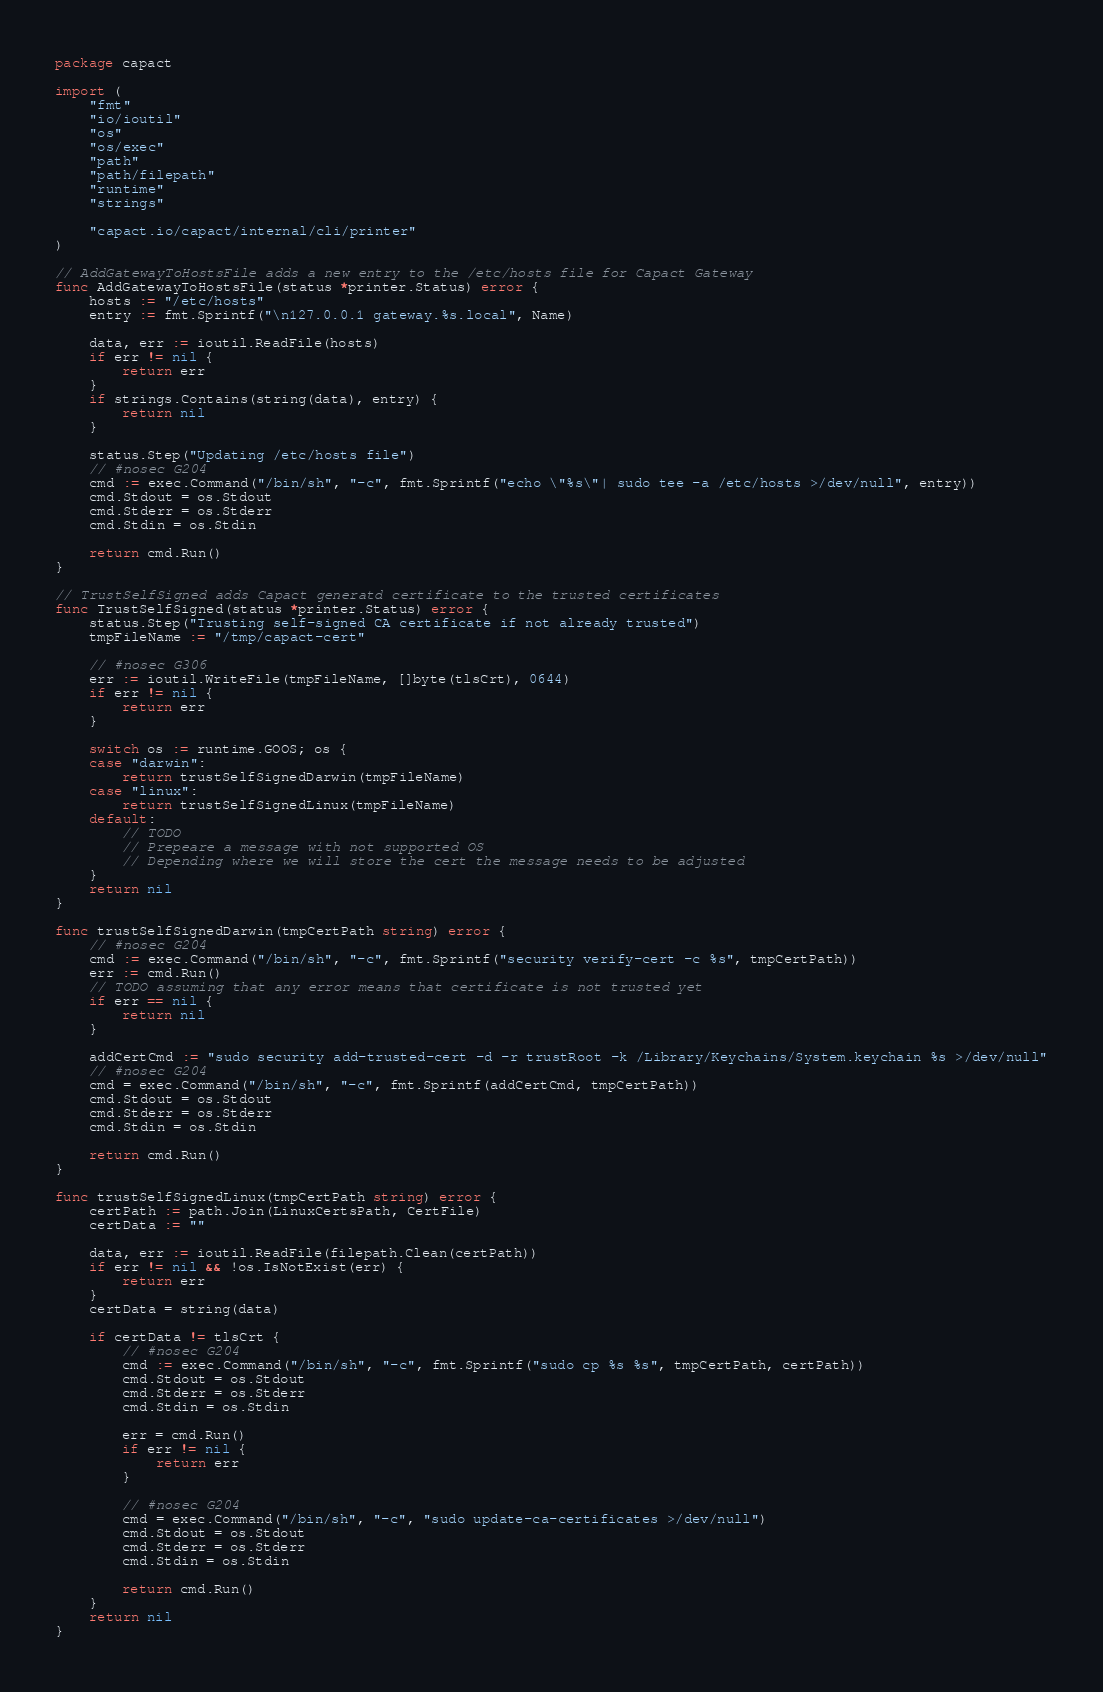Convert code to text. <code><loc_0><loc_0><loc_500><loc_500><_Go_>package capact

import (
	"fmt"
	"io/ioutil"
	"os"
	"os/exec"
	"path"
	"path/filepath"
	"runtime"
	"strings"

	"capact.io/capact/internal/cli/printer"
)

// AddGatewayToHostsFile adds a new entry to the /etc/hosts file for Capact Gateway
func AddGatewayToHostsFile(status *printer.Status) error {
	hosts := "/etc/hosts"
	entry := fmt.Sprintf("\n127.0.0.1 gateway.%s.local", Name)

	data, err := ioutil.ReadFile(hosts)
	if err != nil {
		return err
	}
	if strings.Contains(string(data), entry) {
		return nil
	}

	status.Step("Updating /etc/hosts file")
	// #nosec G204
	cmd := exec.Command("/bin/sh", "-c", fmt.Sprintf("echo \"%s\"| sudo tee -a /etc/hosts >/dev/null", entry))
	cmd.Stdout = os.Stdout
	cmd.Stderr = os.Stderr
	cmd.Stdin = os.Stdin

	return cmd.Run()
}

// TrustSelfSigned adds Capact generatd certificate to the trusted certificates
func TrustSelfSigned(status *printer.Status) error {
	status.Step("Trusting self-signed CA certificate if not already trusted")
	tmpFileName := "/tmp/capact-cert"

	// #nosec G306
	err := ioutil.WriteFile(tmpFileName, []byte(tlsCrt), 0644)
	if err != nil {
		return err
	}

	switch os := runtime.GOOS; os {
	case "darwin":
		return trustSelfSignedDarwin(tmpFileName)
	case "linux":
		return trustSelfSignedLinux(tmpFileName)
	default:
		// TODO
		// Prepeare a message with not supported OS
		// Depending where we will store the cert the message needs to be adjusted
	}
	return nil
}

func trustSelfSignedDarwin(tmpCertPath string) error {
	// #nosec G204
	cmd := exec.Command("/bin/sh", "-c", fmt.Sprintf("security verify-cert -c %s", tmpCertPath))
	err := cmd.Run()
	// TODO assuming that any error means that certificate is not trusted yet
	if err == nil {
		return nil
	}

	addCertCmd := "sudo security add-trusted-cert -d -r trustRoot -k /Library/Keychains/System.keychain %s >/dev/null"
	// #nosec G204
	cmd = exec.Command("/bin/sh", "-c", fmt.Sprintf(addCertCmd, tmpCertPath))
	cmd.Stdout = os.Stdout
	cmd.Stderr = os.Stderr
	cmd.Stdin = os.Stdin

	return cmd.Run()
}

func trustSelfSignedLinux(tmpCertPath string) error {
	certPath := path.Join(LinuxCertsPath, CertFile)
	certData := ""

	data, err := ioutil.ReadFile(filepath.Clean(certPath))
	if err != nil && !os.IsNotExist(err) {
		return err
	}
	certData = string(data)

	if certData != tlsCrt {
		// #nosec G204
		cmd := exec.Command("/bin/sh", "-c", fmt.Sprintf("sudo cp %s %s", tmpCertPath, certPath))
		cmd.Stdout = os.Stdout
		cmd.Stderr = os.Stderr
		cmd.Stdin = os.Stdin

		err = cmd.Run()
		if err != nil {
			return err
		}

		// #nosec G204
		cmd = exec.Command("/bin/sh", "-c", "sudo update-ca-certificates >/dev/null")
		cmd.Stdout = os.Stdout
		cmd.Stderr = os.Stderr
		cmd.Stdin = os.Stdin

		return cmd.Run()
	}
	return nil
}
</code> 